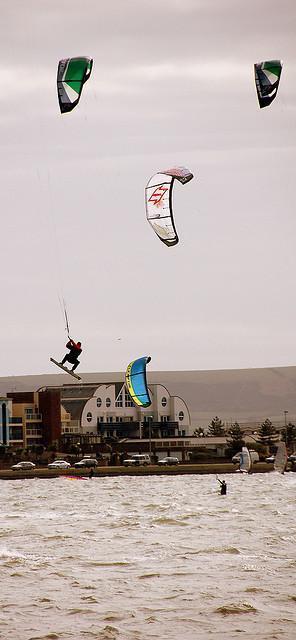How many donuts are in the plate?
Give a very brief answer. 0. 